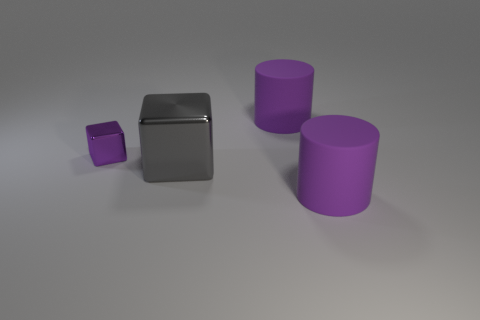Add 2 purple objects. How many objects exist? 6 Subtract 0 blue balls. How many objects are left? 4 Subtract all big purple things. Subtract all purple shiny blocks. How many objects are left? 1 Add 2 purple objects. How many purple objects are left? 5 Add 1 big gray metallic blocks. How many big gray metallic blocks exist? 2 